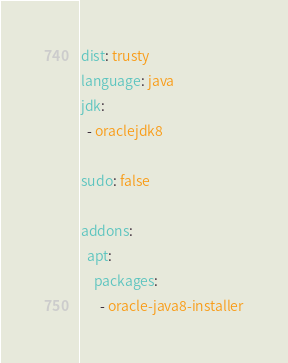Convert code to text. <code><loc_0><loc_0><loc_500><loc_500><_YAML_>dist: trusty
language: java
jdk:
  - oraclejdk8

sudo: false

addons:
  apt:
    packages:
      - oracle-java8-installer</code> 